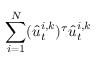<formula> <loc_0><loc_0><loc_500><loc_500>\sum _ { i = 1 } ^ { N } ( \hat { u } _ { t } ^ { i , k } ) ^ { \tau } \hat { u } _ { t } ^ { i , k }</formula> 